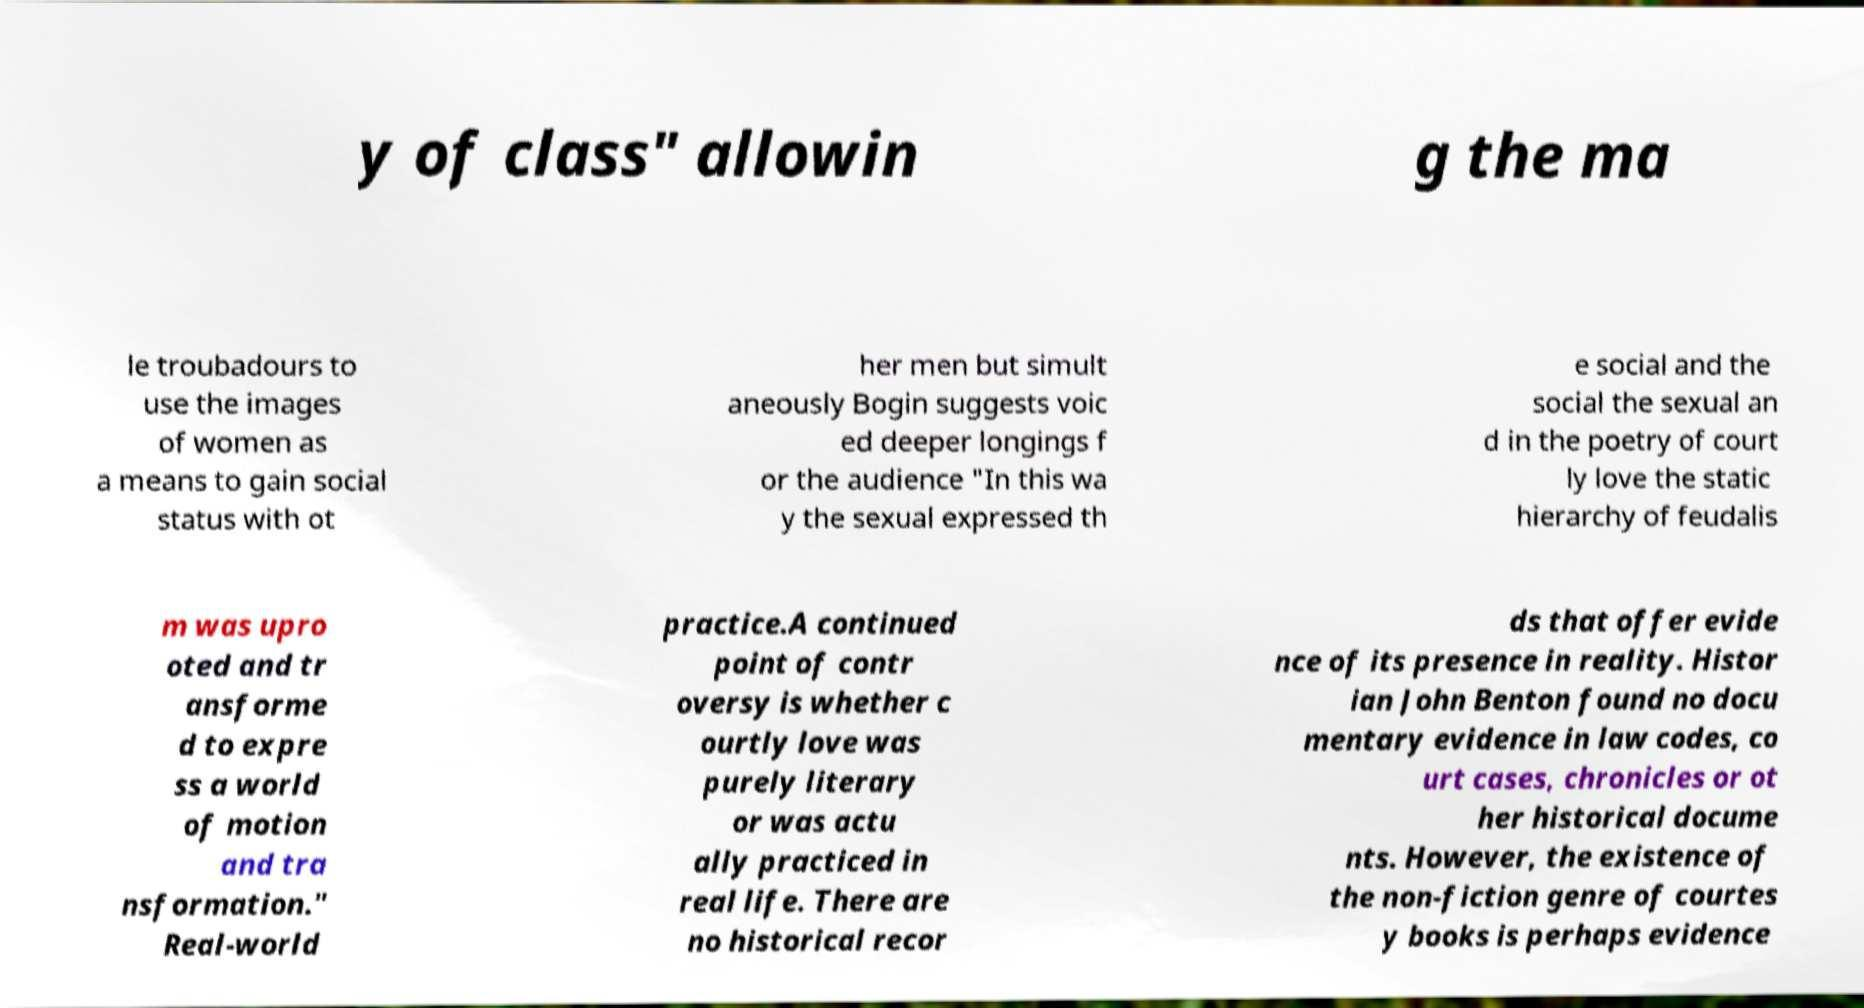What messages or text are displayed in this image? I need them in a readable, typed format. y of class" allowin g the ma le troubadours to use the images of women as a means to gain social status with ot her men but simult aneously Bogin suggests voic ed deeper longings f or the audience "In this wa y the sexual expressed th e social and the social the sexual an d in the poetry of court ly love the static hierarchy of feudalis m was upro oted and tr ansforme d to expre ss a world of motion and tra nsformation." Real-world practice.A continued point of contr oversy is whether c ourtly love was purely literary or was actu ally practiced in real life. There are no historical recor ds that offer evide nce of its presence in reality. Histor ian John Benton found no docu mentary evidence in law codes, co urt cases, chronicles or ot her historical docume nts. However, the existence of the non-fiction genre of courtes y books is perhaps evidence 